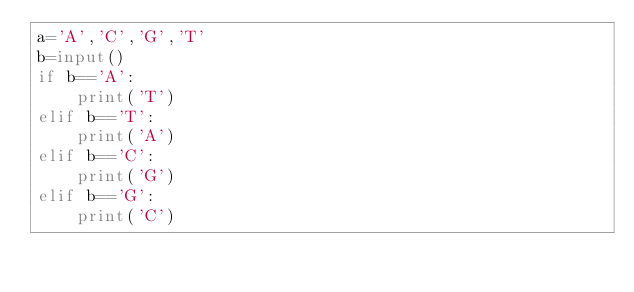<code> <loc_0><loc_0><loc_500><loc_500><_Python_>a='A','C','G','T'
b=input()
if b=='A':
    print('T')
elif b=='T':
    print('A')
elif b=='C':
    print('G')
elif b=='G':
    print('C')
    </code> 